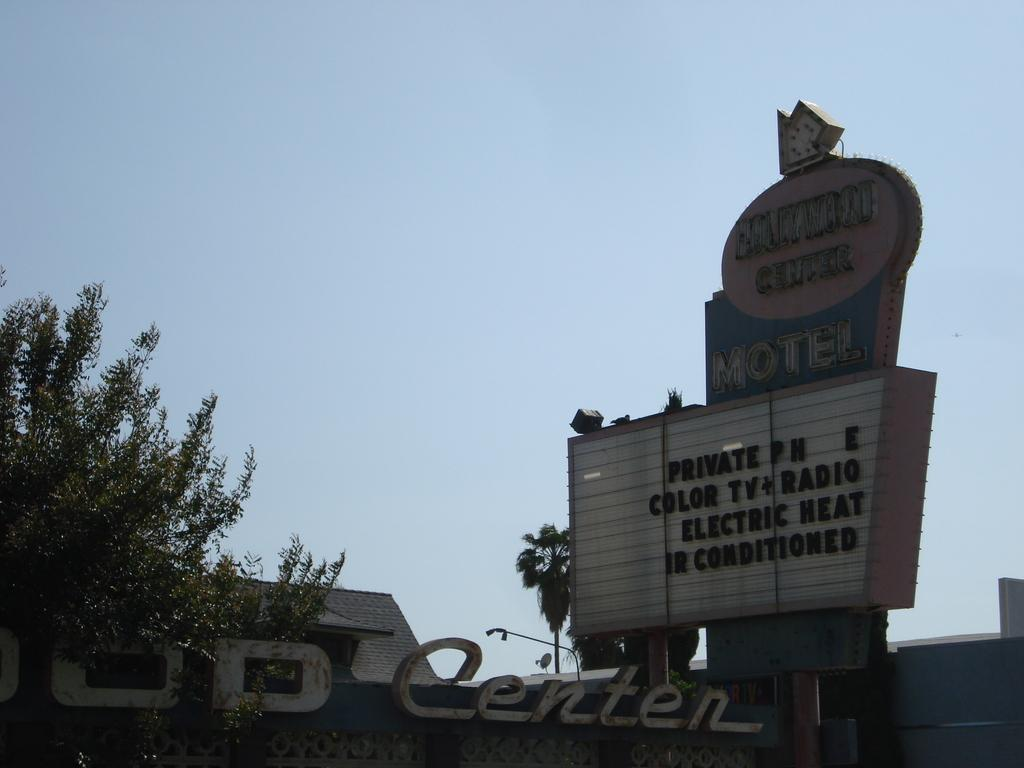What type of vegetation is present in the image? There are trees in the image. What type of structure is visible in the image? There is a building in the image. What object is present in the image that has text on it? There is a board in the image with text on it. What can be seen in the background of the image? The sky is visible in the background of the image. Can you describe the alley where the van and truck are parked in the image? There is no alley, van, or truck present in the image. The image features trees, a building, a board with text, and a visible sky in the background. 